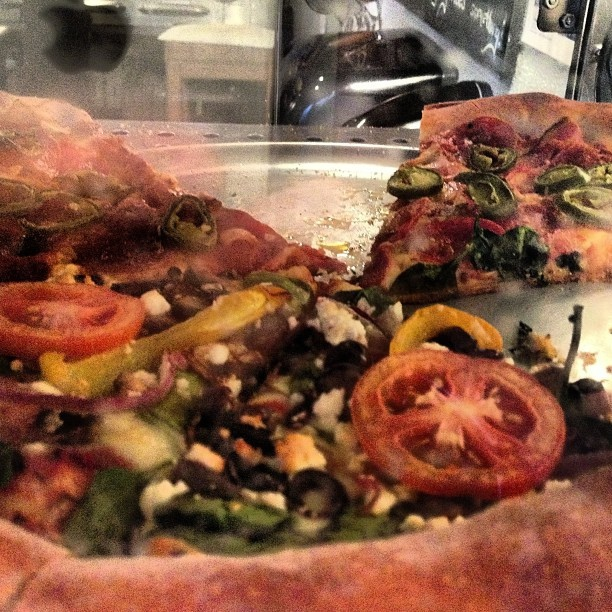Describe the objects in this image and their specific colors. I can see a pizza in gray, black, maroon, and brown tones in this image. 